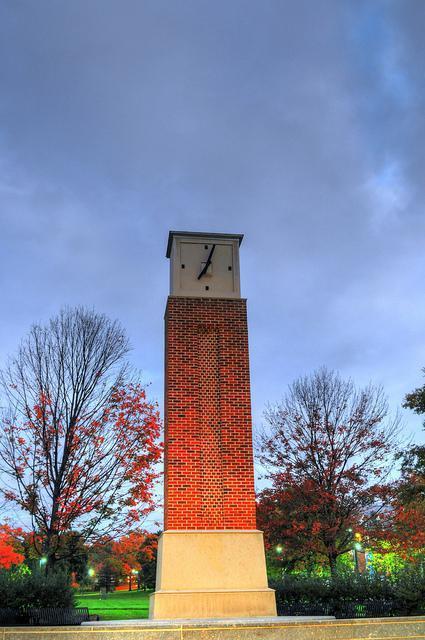How many train cars?
Give a very brief answer. 0. 